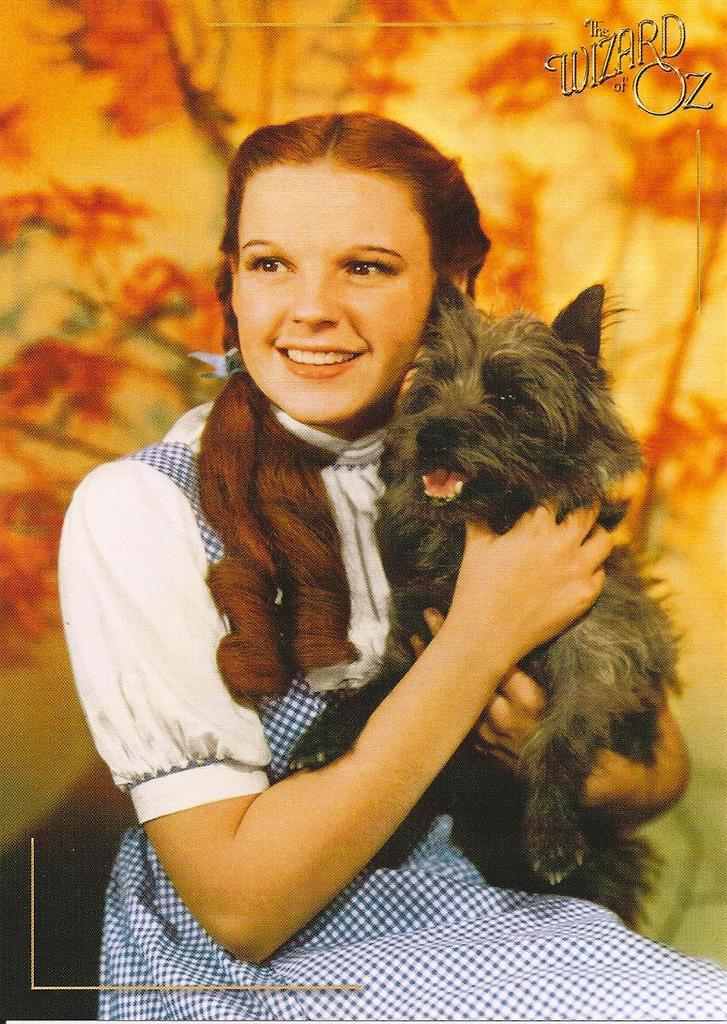Who is the main subject in the image? There is a girl in the image. What is the girl holding in the image? The girl is holding a dog. What can be seen in the background of the image? There is a platform with designs in the background of the image. What is written at the top of the image? There are texts written at the top of the image. What type of brass instrument is the girl playing in the image? There is no brass instrument present in the image; the girl is holding a dog. 